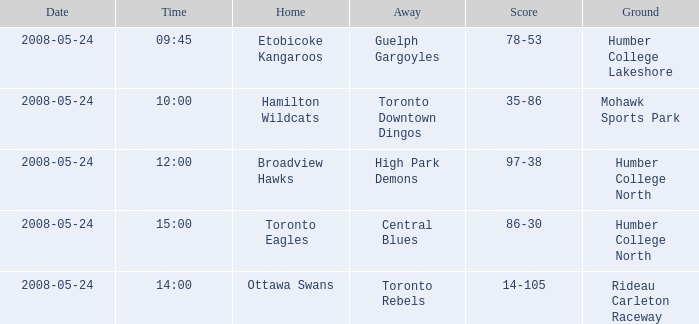What location did the toronto rebels' away team use for their games? Rideau Carleton Raceway. 